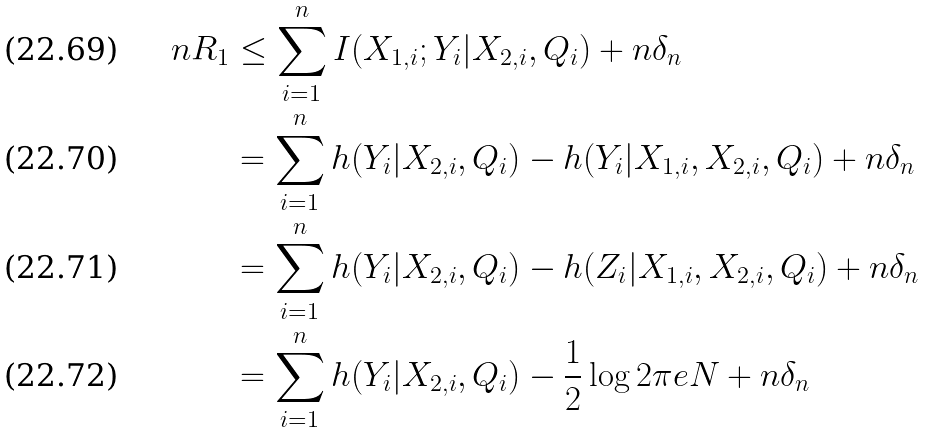Convert formula to latex. <formula><loc_0><loc_0><loc_500><loc_500>n R _ { 1 } & \leq \sum _ { i = 1 } ^ { n } I ( X _ { 1 , i } ; Y _ { i } | X _ { 2 , i } , Q _ { i } ) + n \delta _ { n } \\ & = \sum _ { i = 1 } ^ { n } h ( Y _ { i } | X _ { 2 , i } , Q _ { i } ) - h ( Y _ { i } | X _ { 1 , i } , X _ { 2 , i } , Q _ { i } ) + n \delta _ { n } \\ & = \sum _ { i = 1 } ^ { n } h ( Y _ { i } | X _ { 2 , i } , Q _ { i } ) - h ( Z _ { i } | X _ { 1 , i } , X _ { 2 , i } , Q _ { i } ) + n \delta _ { n } \\ & = \sum _ { i = 1 } ^ { n } h ( Y _ { i } | X _ { 2 , i } , Q _ { i } ) - \frac { 1 } { 2 } \log 2 \pi e N + n \delta _ { n }</formula> 